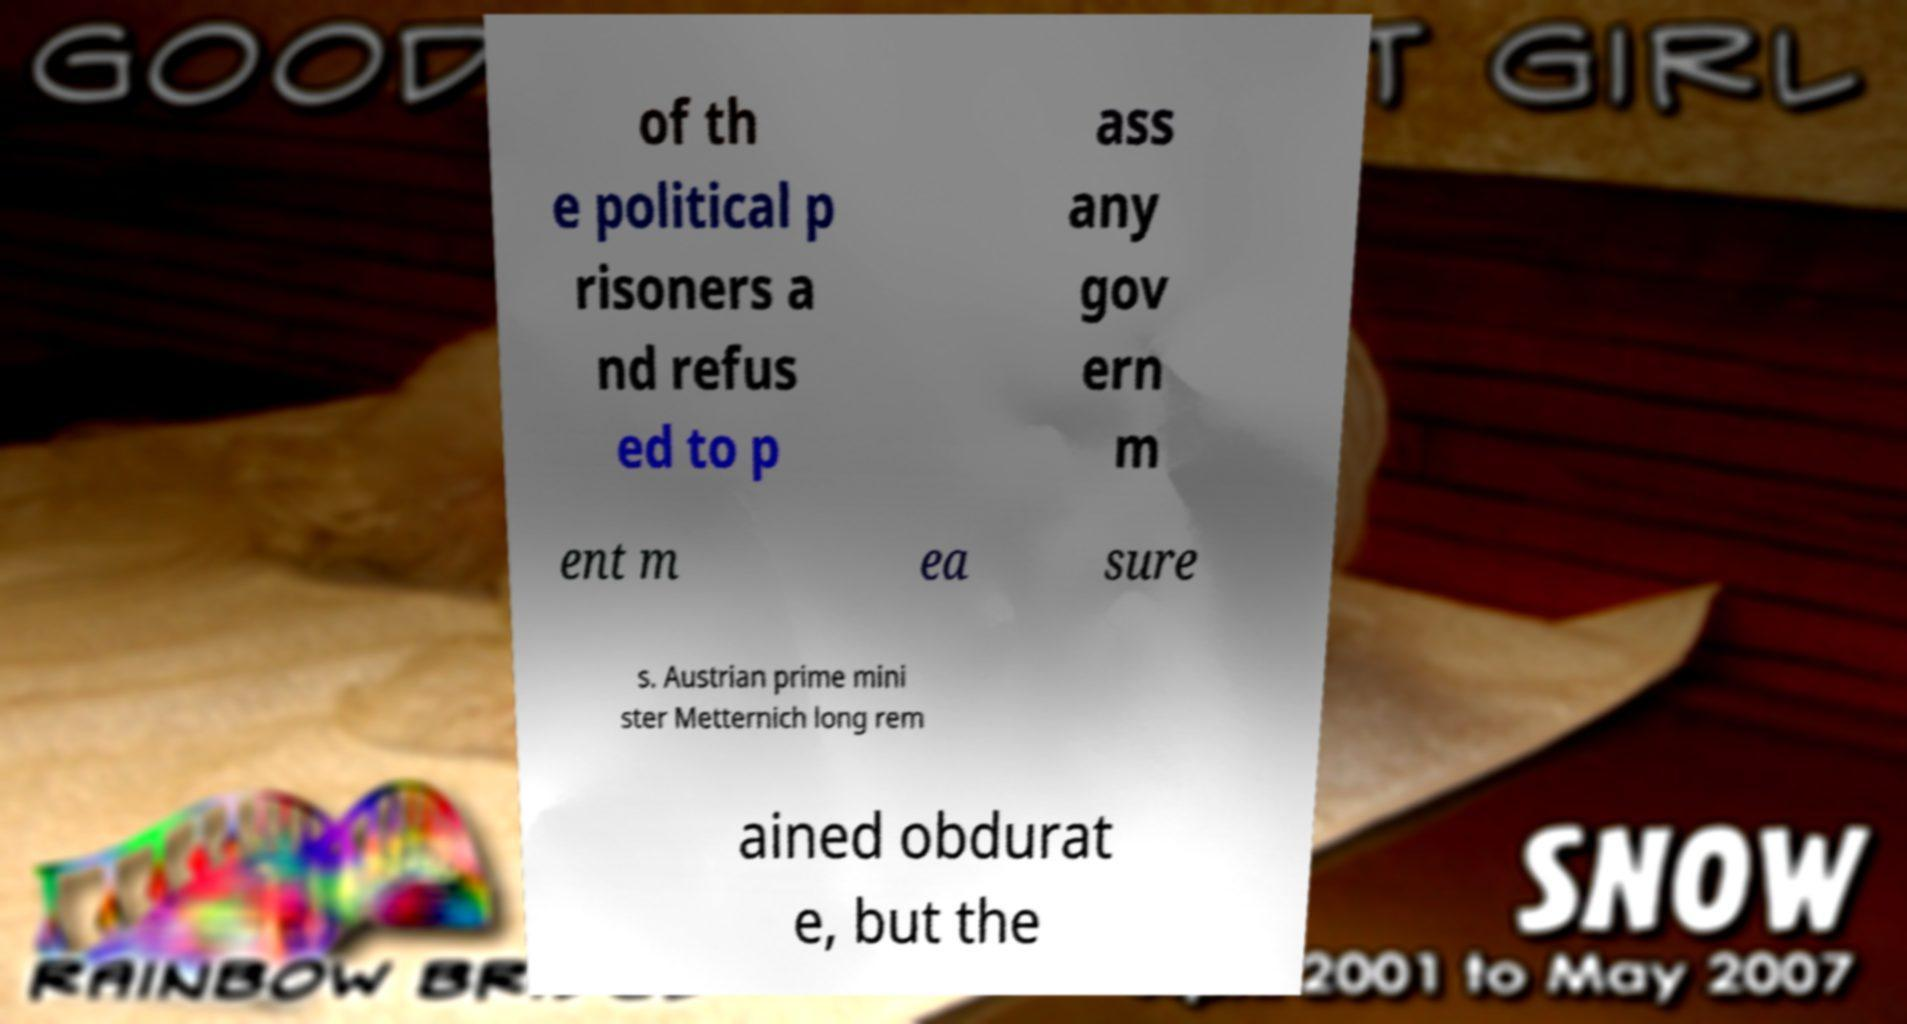Can you read and provide the text displayed in the image?This photo seems to have some interesting text. Can you extract and type it out for me? of th e political p risoners a nd refus ed to p ass any gov ern m ent m ea sure s. Austrian prime mini ster Metternich long rem ained obdurat e, but the 